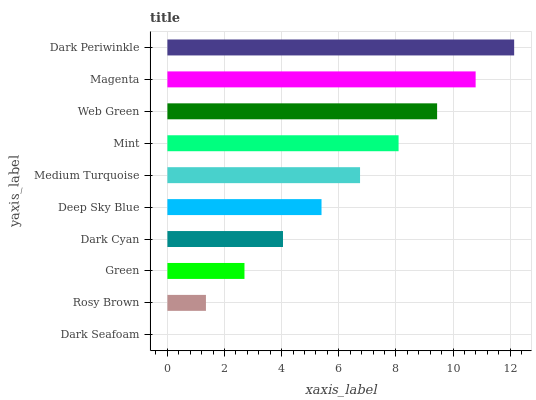Is Dark Seafoam the minimum?
Answer yes or no. Yes. Is Dark Periwinkle the maximum?
Answer yes or no. Yes. Is Rosy Brown the minimum?
Answer yes or no. No. Is Rosy Brown the maximum?
Answer yes or no. No. Is Rosy Brown greater than Dark Seafoam?
Answer yes or no. Yes. Is Dark Seafoam less than Rosy Brown?
Answer yes or no. Yes. Is Dark Seafoam greater than Rosy Brown?
Answer yes or no. No. Is Rosy Brown less than Dark Seafoam?
Answer yes or no. No. Is Medium Turquoise the high median?
Answer yes or no. Yes. Is Deep Sky Blue the low median?
Answer yes or no. Yes. Is Rosy Brown the high median?
Answer yes or no. No. Is Dark Cyan the low median?
Answer yes or no. No. 